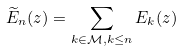Convert formula to latex. <formula><loc_0><loc_0><loc_500><loc_500>\widetilde { E } _ { n } ( z ) = \sum _ { k \in \mathcal { M } , k \leq n } E _ { k } ( z )</formula> 